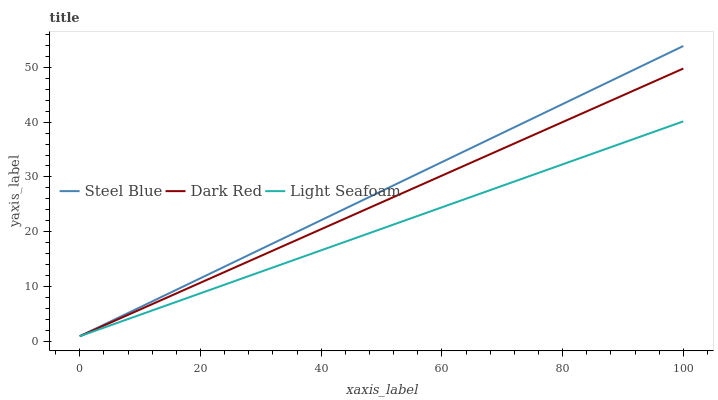Does Light Seafoam have the minimum area under the curve?
Answer yes or no. Yes. Does Steel Blue have the maximum area under the curve?
Answer yes or no. Yes. Does Steel Blue have the minimum area under the curve?
Answer yes or no. No. Does Light Seafoam have the maximum area under the curve?
Answer yes or no. No. Is Steel Blue the smoothest?
Answer yes or no. Yes. Is Dark Red the roughest?
Answer yes or no. Yes. Is Light Seafoam the smoothest?
Answer yes or no. No. Is Light Seafoam the roughest?
Answer yes or no. No. Does Dark Red have the lowest value?
Answer yes or no. Yes. Does Steel Blue have the highest value?
Answer yes or no. Yes. Does Light Seafoam have the highest value?
Answer yes or no. No. Does Dark Red intersect Steel Blue?
Answer yes or no. Yes. Is Dark Red less than Steel Blue?
Answer yes or no. No. Is Dark Red greater than Steel Blue?
Answer yes or no. No. 